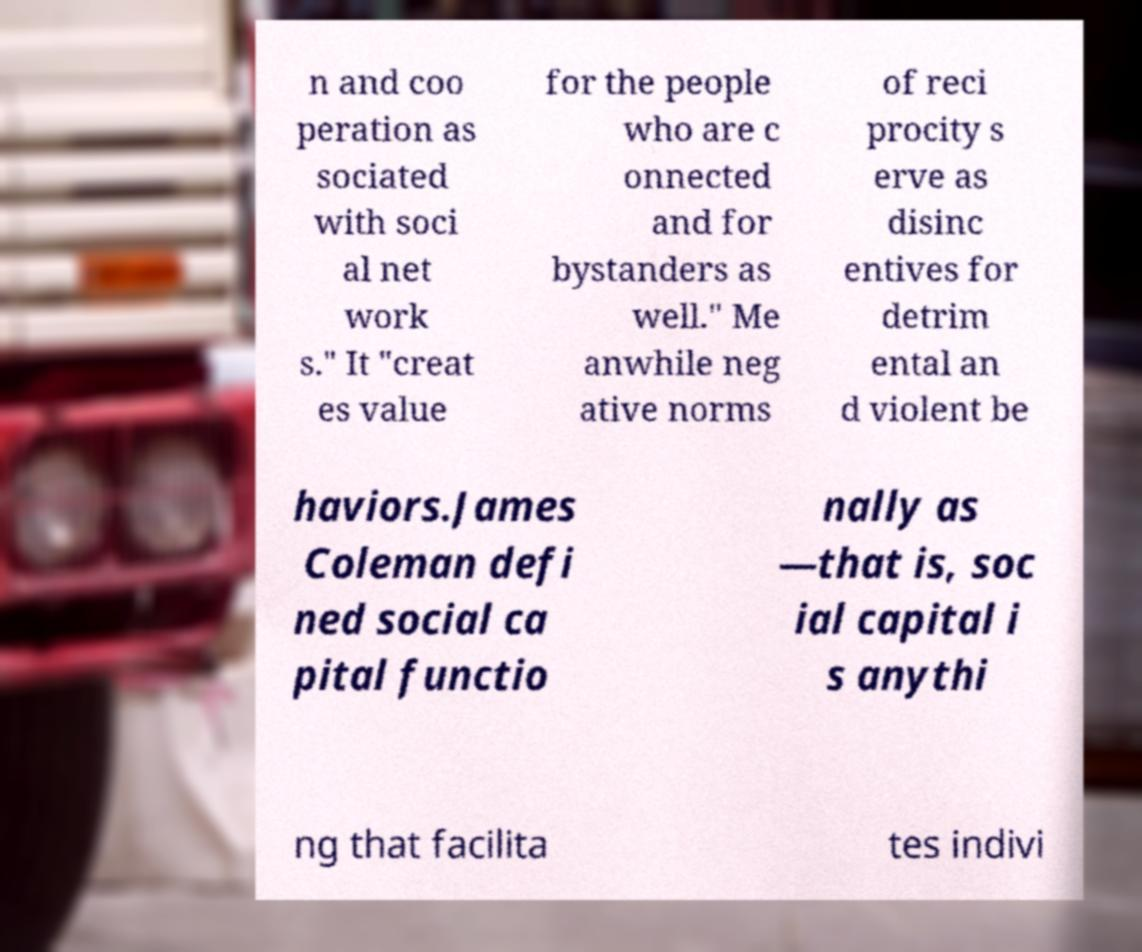Can you read and provide the text displayed in the image?This photo seems to have some interesting text. Can you extract and type it out for me? n and coo peration as sociated with soci al net work s." It "creat es value for the people who are c onnected and for bystanders as well." Me anwhile neg ative norms of reci procity s erve as disinc entives for detrim ental an d violent be haviors.James Coleman defi ned social ca pital functio nally as —that is, soc ial capital i s anythi ng that facilita tes indivi 